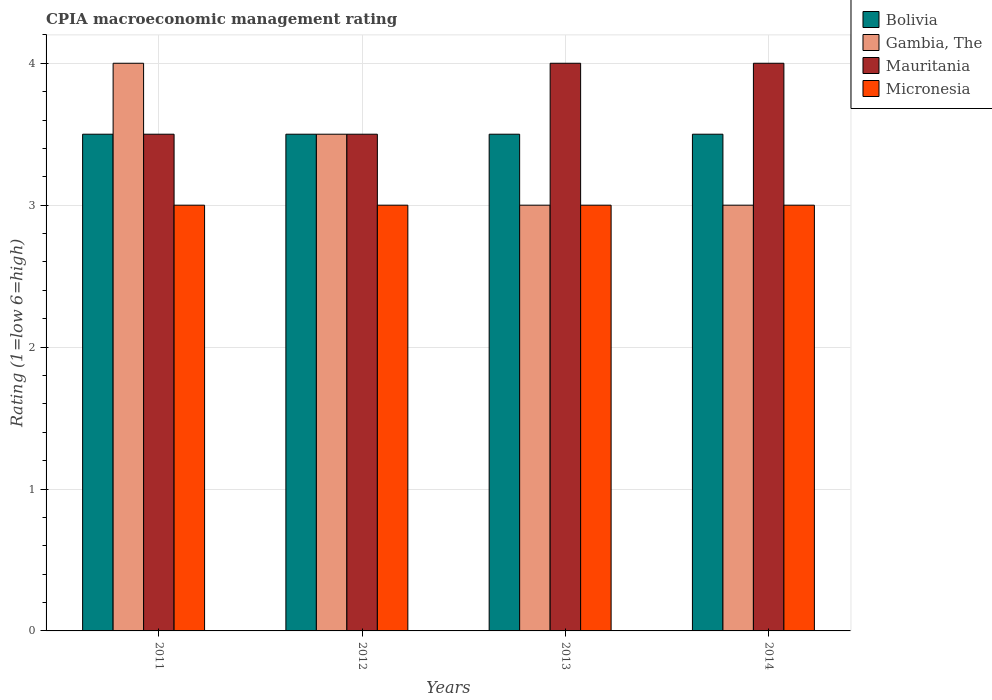How many bars are there on the 4th tick from the right?
Offer a very short reply. 4. In how many cases, is the number of bars for a given year not equal to the number of legend labels?
Offer a very short reply. 0. In which year was the CPIA rating in Micronesia maximum?
Keep it short and to the point. 2011. What is the difference between the CPIA rating in Bolivia in 2011 and that in 2014?
Provide a short and direct response. 0. What is the difference between the CPIA rating in Gambia, The in 2011 and the CPIA rating in Mauritania in 2014?
Offer a terse response. 0. What is the average CPIA rating in Gambia, The per year?
Give a very brief answer. 3.38. Is the CPIA rating in Bolivia in 2012 less than that in 2014?
Provide a succinct answer. No. What does the 2nd bar from the left in 2011 represents?
Provide a short and direct response. Gambia, The. What does the 2nd bar from the right in 2011 represents?
Offer a very short reply. Mauritania. Is it the case that in every year, the sum of the CPIA rating in Mauritania and CPIA rating in Bolivia is greater than the CPIA rating in Micronesia?
Provide a short and direct response. Yes. Are all the bars in the graph horizontal?
Provide a succinct answer. No. How many years are there in the graph?
Your answer should be very brief. 4. Does the graph contain any zero values?
Offer a very short reply. No. Does the graph contain grids?
Provide a succinct answer. Yes. Where does the legend appear in the graph?
Offer a very short reply. Top right. How are the legend labels stacked?
Provide a succinct answer. Vertical. What is the title of the graph?
Provide a short and direct response. CPIA macroeconomic management rating. Does "Bolivia" appear as one of the legend labels in the graph?
Your response must be concise. Yes. What is the label or title of the Y-axis?
Your answer should be very brief. Rating (1=low 6=high). What is the Rating (1=low 6=high) in Bolivia in 2011?
Keep it short and to the point. 3.5. What is the Rating (1=low 6=high) of Mauritania in 2011?
Offer a terse response. 3.5. What is the Rating (1=low 6=high) of Micronesia in 2011?
Offer a terse response. 3. What is the Rating (1=low 6=high) in Bolivia in 2012?
Keep it short and to the point. 3.5. What is the Rating (1=low 6=high) of Mauritania in 2012?
Keep it short and to the point. 3.5. What is the Rating (1=low 6=high) of Bolivia in 2013?
Provide a succinct answer. 3.5. What is the Rating (1=low 6=high) of Bolivia in 2014?
Offer a very short reply. 3.5. What is the Rating (1=low 6=high) of Micronesia in 2014?
Offer a very short reply. 3. Across all years, what is the minimum Rating (1=low 6=high) of Gambia, The?
Give a very brief answer. 3. Across all years, what is the minimum Rating (1=low 6=high) of Mauritania?
Ensure brevity in your answer.  3.5. Across all years, what is the minimum Rating (1=low 6=high) in Micronesia?
Provide a succinct answer. 3. What is the total Rating (1=low 6=high) in Gambia, The in the graph?
Your answer should be compact. 13.5. What is the difference between the Rating (1=low 6=high) in Bolivia in 2011 and that in 2012?
Offer a terse response. 0. What is the difference between the Rating (1=low 6=high) of Gambia, The in 2011 and that in 2012?
Keep it short and to the point. 0.5. What is the difference between the Rating (1=low 6=high) of Micronesia in 2011 and that in 2012?
Your answer should be compact. 0. What is the difference between the Rating (1=low 6=high) of Gambia, The in 2011 and that in 2013?
Your answer should be compact. 1. What is the difference between the Rating (1=low 6=high) in Mauritania in 2011 and that in 2013?
Give a very brief answer. -0.5. What is the difference between the Rating (1=low 6=high) in Micronesia in 2011 and that in 2013?
Ensure brevity in your answer.  0. What is the difference between the Rating (1=low 6=high) of Bolivia in 2011 and that in 2014?
Give a very brief answer. 0. What is the difference between the Rating (1=low 6=high) of Mauritania in 2011 and that in 2014?
Provide a short and direct response. -0.5. What is the difference between the Rating (1=low 6=high) in Bolivia in 2012 and that in 2013?
Make the answer very short. 0. What is the difference between the Rating (1=low 6=high) in Gambia, The in 2012 and that in 2013?
Ensure brevity in your answer.  0.5. What is the difference between the Rating (1=low 6=high) of Bolivia in 2012 and that in 2014?
Give a very brief answer. 0. What is the difference between the Rating (1=low 6=high) of Gambia, The in 2012 and that in 2014?
Keep it short and to the point. 0.5. What is the difference between the Rating (1=low 6=high) of Mauritania in 2012 and that in 2014?
Provide a short and direct response. -0.5. What is the difference between the Rating (1=low 6=high) in Micronesia in 2012 and that in 2014?
Make the answer very short. 0. What is the difference between the Rating (1=low 6=high) of Gambia, The in 2013 and that in 2014?
Keep it short and to the point. 0. What is the difference between the Rating (1=low 6=high) of Mauritania in 2013 and that in 2014?
Give a very brief answer. 0. What is the difference between the Rating (1=low 6=high) of Micronesia in 2013 and that in 2014?
Offer a terse response. 0. What is the difference between the Rating (1=low 6=high) of Bolivia in 2011 and the Rating (1=low 6=high) of Gambia, The in 2012?
Give a very brief answer. 0. What is the difference between the Rating (1=low 6=high) in Bolivia in 2011 and the Rating (1=low 6=high) in Mauritania in 2012?
Give a very brief answer. 0. What is the difference between the Rating (1=low 6=high) in Bolivia in 2011 and the Rating (1=low 6=high) in Micronesia in 2012?
Ensure brevity in your answer.  0.5. What is the difference between the Rating (1=low 6=high) of Gambia, The in 2011 and the Rating (1=low 6=high) of Micronesia in 2012?
Your response must be concise. 1. What is the difference between the Rating (1=low 6=high) of Mauritania in 2011 and the Rating (1=low 6=high) of Micronesia in 2012?
Give a very brief answer. 0.5. What is the difference between the Rating (1=low 6=high) in Bolivia in 2011 and the Rating (1=low 6=high) in Mauritania in 2013?
Offer a very short reply. -0.5. What is the difference between the Rating (1=low 6=high) in Gambia, The in 2011 and the Rating (1=low 6=high) in Mauritania in 2013?
Offer a very short reply. 0. What is the difference between the Rating (1=low 6=high) of Bolivia in 2011 and the Rating (1=low 6=high) of Micronesia in 2014?
Provide a short and direct response. 0.5. What is the difference between the Rating (1=low 6=high) in Gambia, The in 2011 and the Rating (1=low 6=high) in Mauritania in 2014?
Keep it short and to the point. 0. What is the difference between the Rating (1=low 6=high) in Gambia, The in 2011 and the Rating (1=low 6=high) in Micronesia in 2014?
Your answer should be compact. 1. What is the difference between the Rating (1=low 6=high) in Mauritania in 2011 and the Rating (1=low 6=high) in Micronesia in 2014?
Provide a succinct answer. 0.5. What is the difference between the Rating (1=low 6=high) of Bolivia in 2012 and the Rating (1=low 6=high) of Gambia, The in 2013?
Offer a terse response. 0.5. What is the difference between the Rating (1=low 6=high) of Bolivia in 2012 and the Rating (1=low 6=high) of Mauritania in 2013?
Ensure brevity in your answer.  -0.5. What is the difference between the Rating (1=low 6=high) in Gambia, The in 2012 and the Rating (1=low 6=high) in Mauritania in 2013?
Your answer should be compact. -0.5. What is the difference between the Rating (1=low 6=high) of Gambia, The in 2012 and the Rating (1=low 6=high) of Micronesia in 2013?
Make the answer very short. 0.5. What is the difference between the Rating (1=low 6=high) of Mauritania in 2012 and the Rating (1=low 6=high) of Micronesia in 2013?
Provide a short and direct response. 0.5. What is the difference between the Rating (1=low 6=high) of Bolivia in 2012 and the Rating (1=low 6=high) of Gambia, The in 2014?
Make the answer very short. 0.5. What is the difference between the Rating (1=low 6=high) of Bolivia in 2012 and the Rating (1=low 6=high) of Micronesia in 2014?
Make the answer very short. 0.5. What is the difference between the Rating (1=low 6=high) of Bolivia in 2013 and the Rating (1=low 6=high) of Gambia, The in 2014?
Your answer should be compact. 0.5. What is the difference between the Rating (1=low 6=high) in Bolivia in 2013 and the Rating (1=low 6=high) in Mauritania in 2014?
Keep it short and to the point. -0.5. What is the difference between the Rating (1=low 6=high) in Gambia, The in 2013 and the Rating (1=low 6=high) in Mauritania in 2014?
Offer a very short reply. -1. What is the difference between the Rating (1=low 6=high) of Gambia, The in 2013 and the Rating (1=low 6=high) of Micronesia in 2014?
Offer a terse response. 0. What is the difference between the Rating (1=low 6=high) of Mauritania in 2013 and the Rating (1=low 6=high) of Micronesia in 2014?
Your response must be concise. 1. What is the average Rating (1=low 6=high) of Gambia, The per year?
Provide a short and direct response. 3.38. What is the average Rating (1=low 6=high) of Mauritania per year?
Offer a very short reply. 3.75. In the year 2011, what is the difference between the Rating (1=low 6=high) in Bolivia and Rating (1=low 6=high) in Gambia, The?
Ensure brevity in your answer.  -0.5. In the year 2011, what is the difference between the Rating (1=low 6=high) of Gambia, The and Rating (1=low 6=high) of Mauritania?
Keep it short and to the point. 0.5. In the year 2012, what is the difference between the Rating (1=low 6=high) in Gambia, The and Rating (1=low 6=high) in Micronesia?
Your answer should be compact. 0.5. In the year 2012, what is the difference between the Rating (1=low 6=high) in Mauritania and Rating (1=low 6=high) in Micronesia?
Ensure brevity in your answer.  0.5. In the year 2013, what is the difference between the Rating (1=low 6=high) in Bolivia and Rating (1=low 6=high) in Gambia, The?
Your answer should be compact. 0.5. In the year 2013, what is the difference between the Rating (1=low 6=high) of Bolivia and Rating (1=low 6=high) of Mauritania?
Ensure brevity in your answer.  -0.5. In the year 2014, what is the difference between the Rating (1=low 6=high) of Bolivia and Rating (1=low 6=high) of Gambia, The?
Make the answer very short. 0.5. In the year 2014, what is the difference between the Rating (1=low 6=high) in Bolivia and Rating (1=low 6=high) in Mauritania?
Your answer should be very brief. -0.5. In the year 2014, what is the difference between the Rating (1=low 6=high) of Gambia, The and Rating (1=low 6=high) of Mauritania?
Ensure brevity in your answer.  -1. In the year 2014, what is the difference between the Rating (1=low 6=high) of Gambia, The and Rating (1=low 6=high) of Micronesia?
Make the answer very short. 0. In the year 2014, what is the difference between the Rating (1=low 6=high) in Mauritania and Rating (1=low 6=high) in Micronesia?
Your answer should be very brief. 1. What is the ratio of the Rating (1=low 6=high) of Bolivia in 2011 to that in 2012?
Ensure brevity in your answer.  1. What is the ratio of the Rating (1=low 6=high) in Mauritania in 2011 to that in 2012?
Offer a very short reply. 1. What is the ratio of the Rating (1=low 6=high) in Bolivia in 2011 to that in 2013?
Provide a succinct answer. 1. What is the ratio of the Rating (1=low 6=high) in Gambia, The in 2011 to that in 2013?
Make the answer very short. 1.33. What is the ratio of the Rating (1=low 6=high) in Micronesia in 2011 to that in 2013?
Provide a short and direct response. 1. What is the ratio of the Rating (1=low 6=high) in Gambia, The in 2011 to that in 2014?
Provide a short and direct response. 1.33. What is the ratio of the Rating (1=low 6=high) of Micronesia in 2011 to that in 2014?
Your answer should be very brief. 1. What is the ratio of the Rating (1=low 6=high) in Gambia, The in 2012 to that in 2014?
Your response must be concise. 1.17. What is the ratio of the Rating (1=low 6=high) in Gambia, The in 2013 to that in 2014?
Offer a terse response. 1. What is the ratio of the Rating (1=low 6=high) of Micronesia in 2013 to that in 2014?
Give a very brief answer. 1. What is the difference between the highest and the second highest Rating (1=low 6=high) in Gambia, The?
Make the answer very short. 0.5. What is the difference between the highest and the second highest Rating (1=low 6=high) in Micronesia?
Offer a very short reply. 0. What is the difference between the highest and the lowest Rating (1=low 6=high) of Gambia, The?
Ensure brevity in your answer.  1. What is the difference between the highest and the lowest Rating (1=low 6=high) of Micronesia?
Give a very brief answer. 0. 